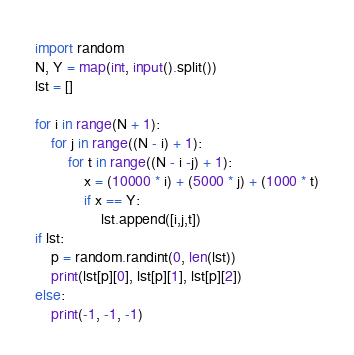Convert code to text. <code><loc_0><loc_0><loc_500><loc_500><_Python_>import random
N, Y = map(int, input().split())
lst = []
 
for i in range(N + 1):
    for j in range((N - i) + 1):
        for t in range((N - i -j) + 1):
            x = (10000 * i) + (5000 * j) + (1000 * t)
            if x == Y:
                lst.append([i,j,t])
if lst:
  	p = random.randint(0, len(lst))
    print(lst[p][0], lst[p][1], lst[p][2])
else:
    print(-1, -1, -1)</code> 